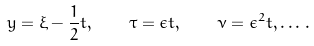<formula> <loc_0><loc_0><loc_500><loc_500>y = \xi - \frac { 1 } { 2 } t , \quad \tau = \epsilon t , \quad \nu = \epsilon ^ { 2 } t , \dots \, .</formula> 